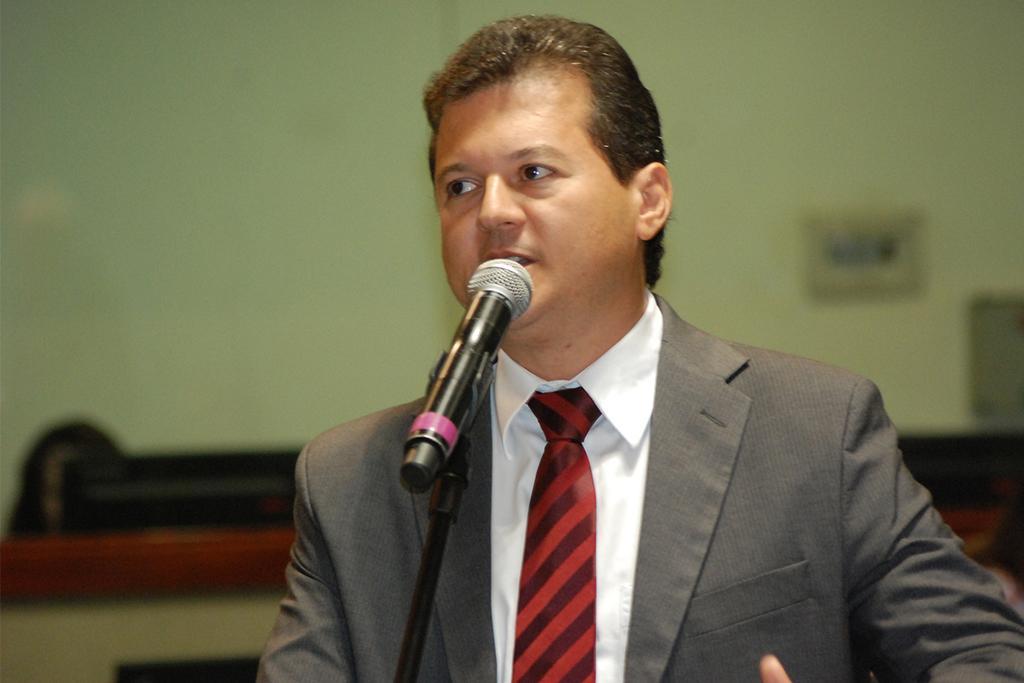How would you summarize this image in a sentence or two? In this image we can see a person is talking, there is a mic in front of him, also we can see the wall, and the background is blurred. 